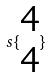<formula> <loc_0><loc_0><loc_500><loc_500>s \{ \begin{matrix} 4 \\ 4 \end{matrix} \}</formula> 